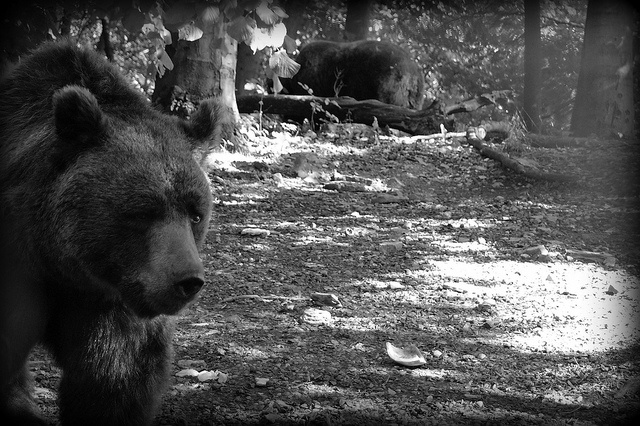Describe the objects in this image and their specific colors. I can see bear in black, gray, and lightgray tones and elephant in black, gray, and lightgray tones in this image. 